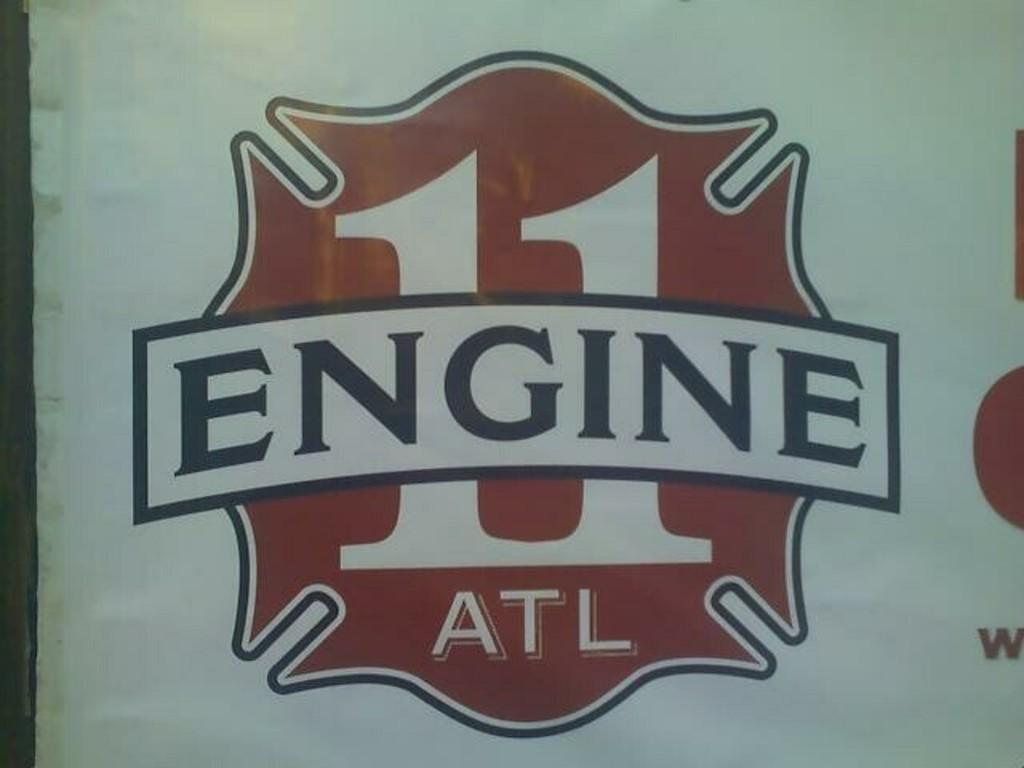<image>
Create a compact narrative representing the image presented. an engine 11 that has red and black writing 